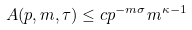<formula> <loc_0><loc_0><loc_500><loc_500>A ( p , m , \tau ) \leq c p ^ { - m \sigma } m ^ { \kappa - 1 }</formula> 